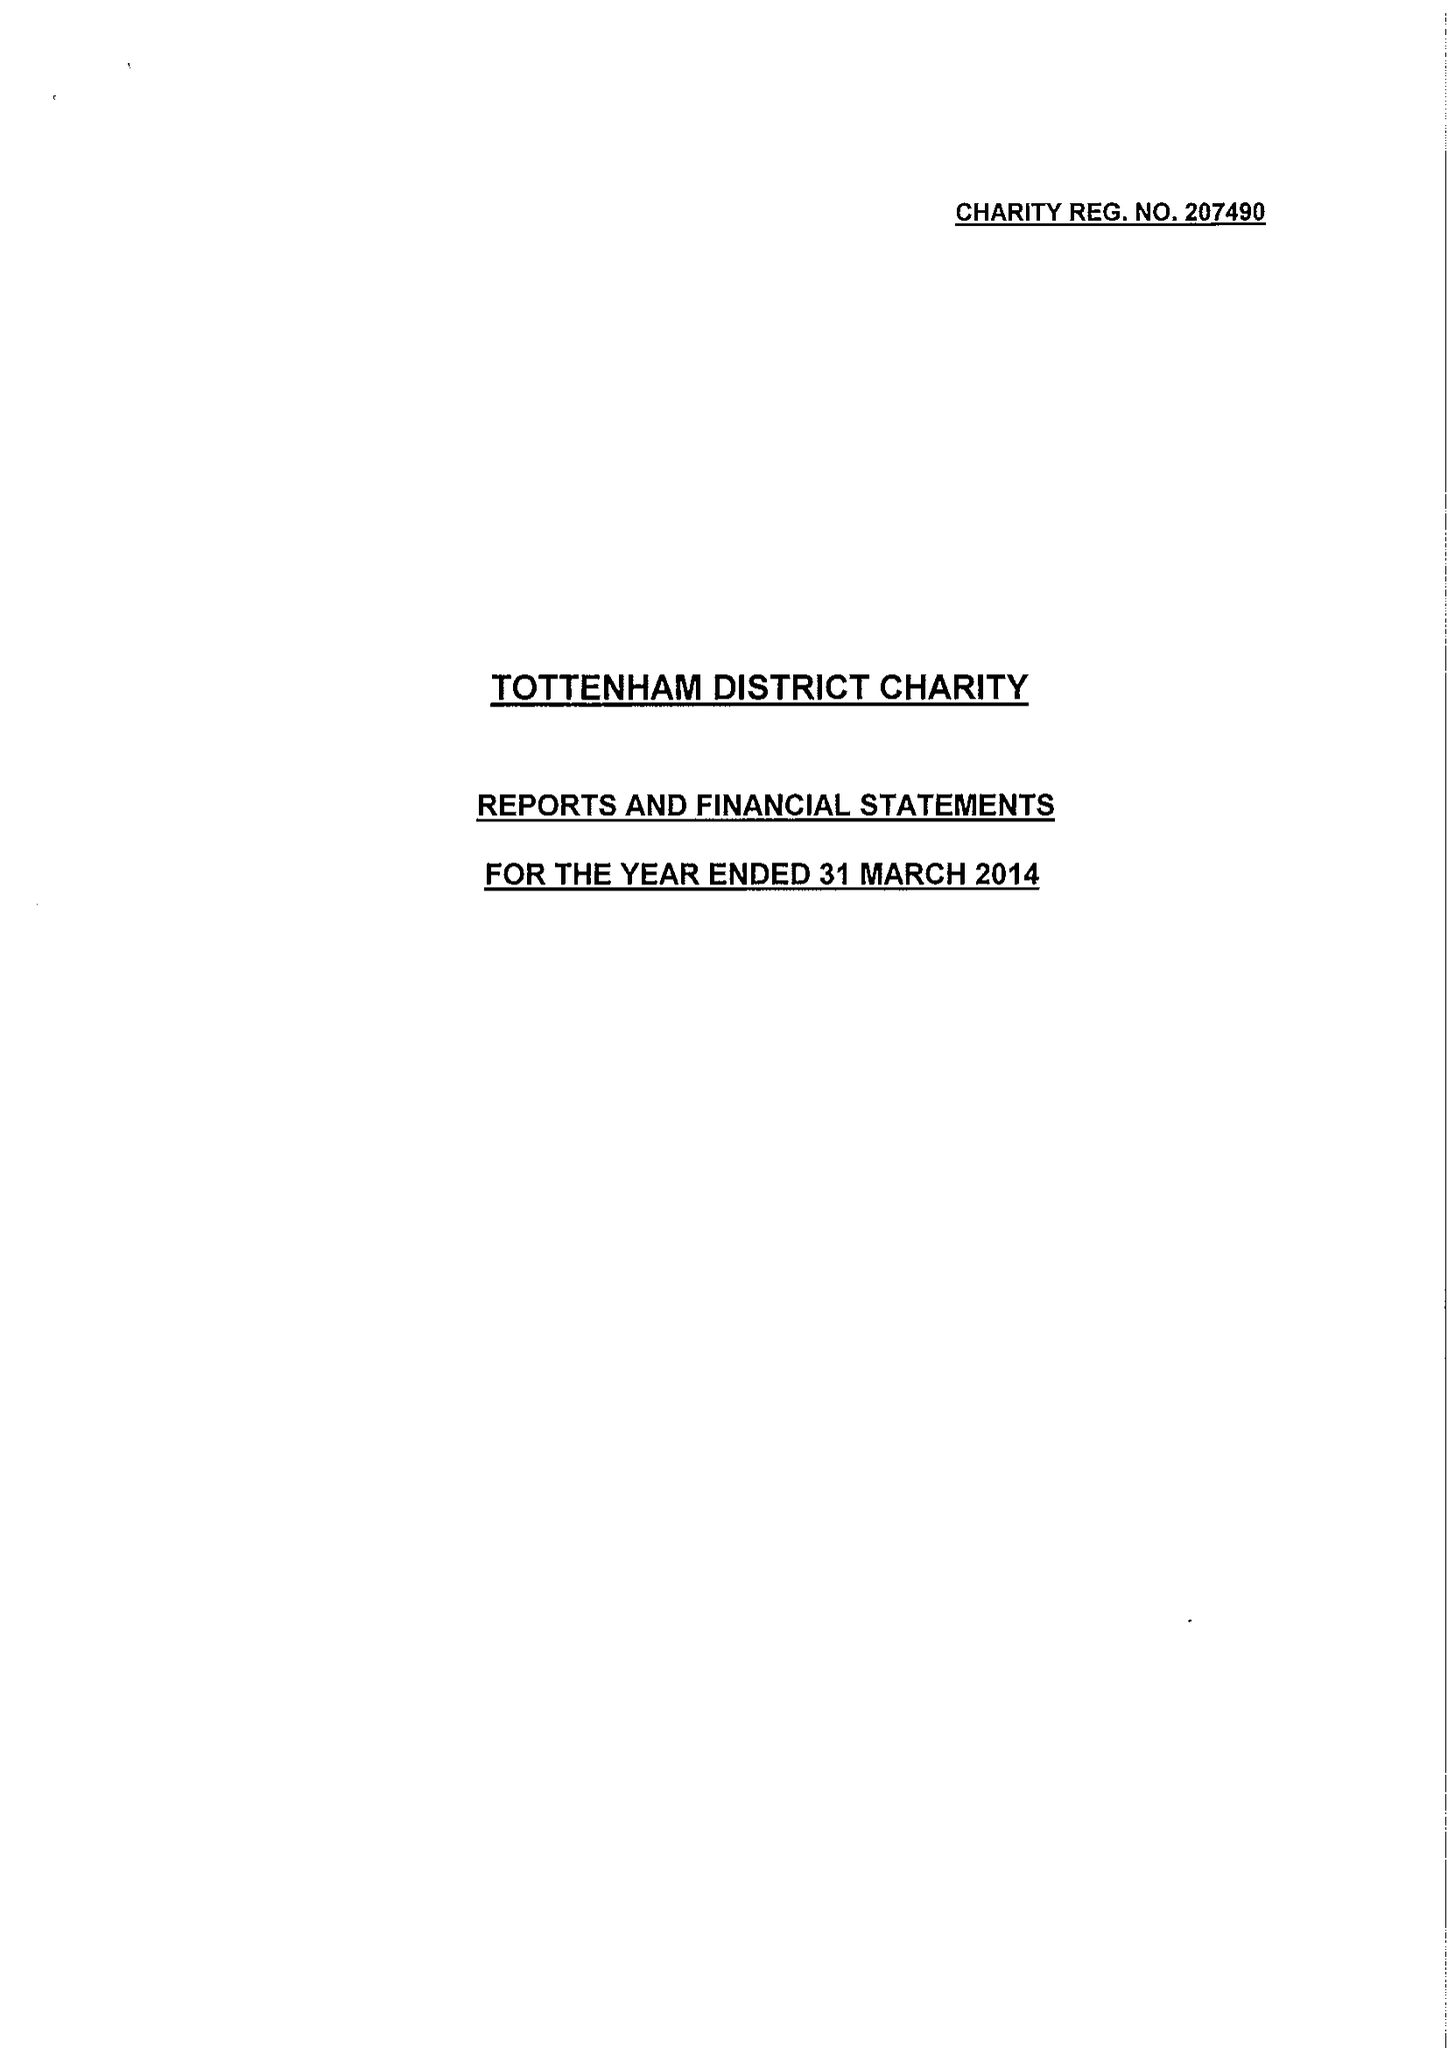What is the value for the charity_number?
Answer the question using a single word or phrase. 207490 